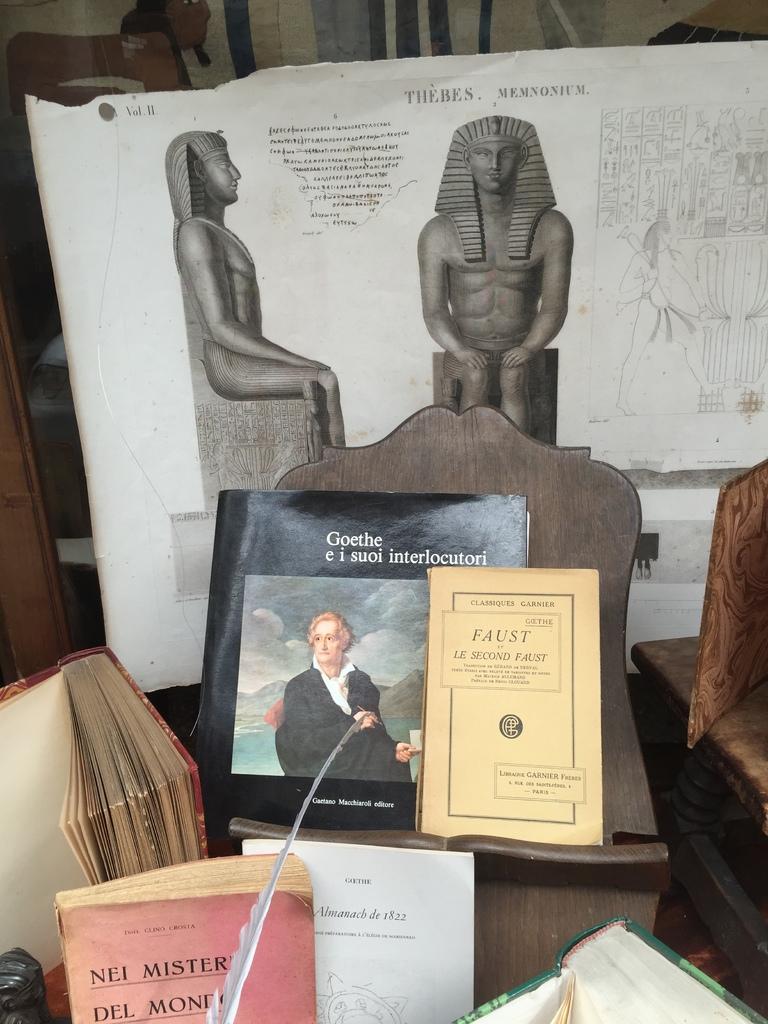What is the black book?
Offer a very short reply. Goethe e i suoi interlocutori. 